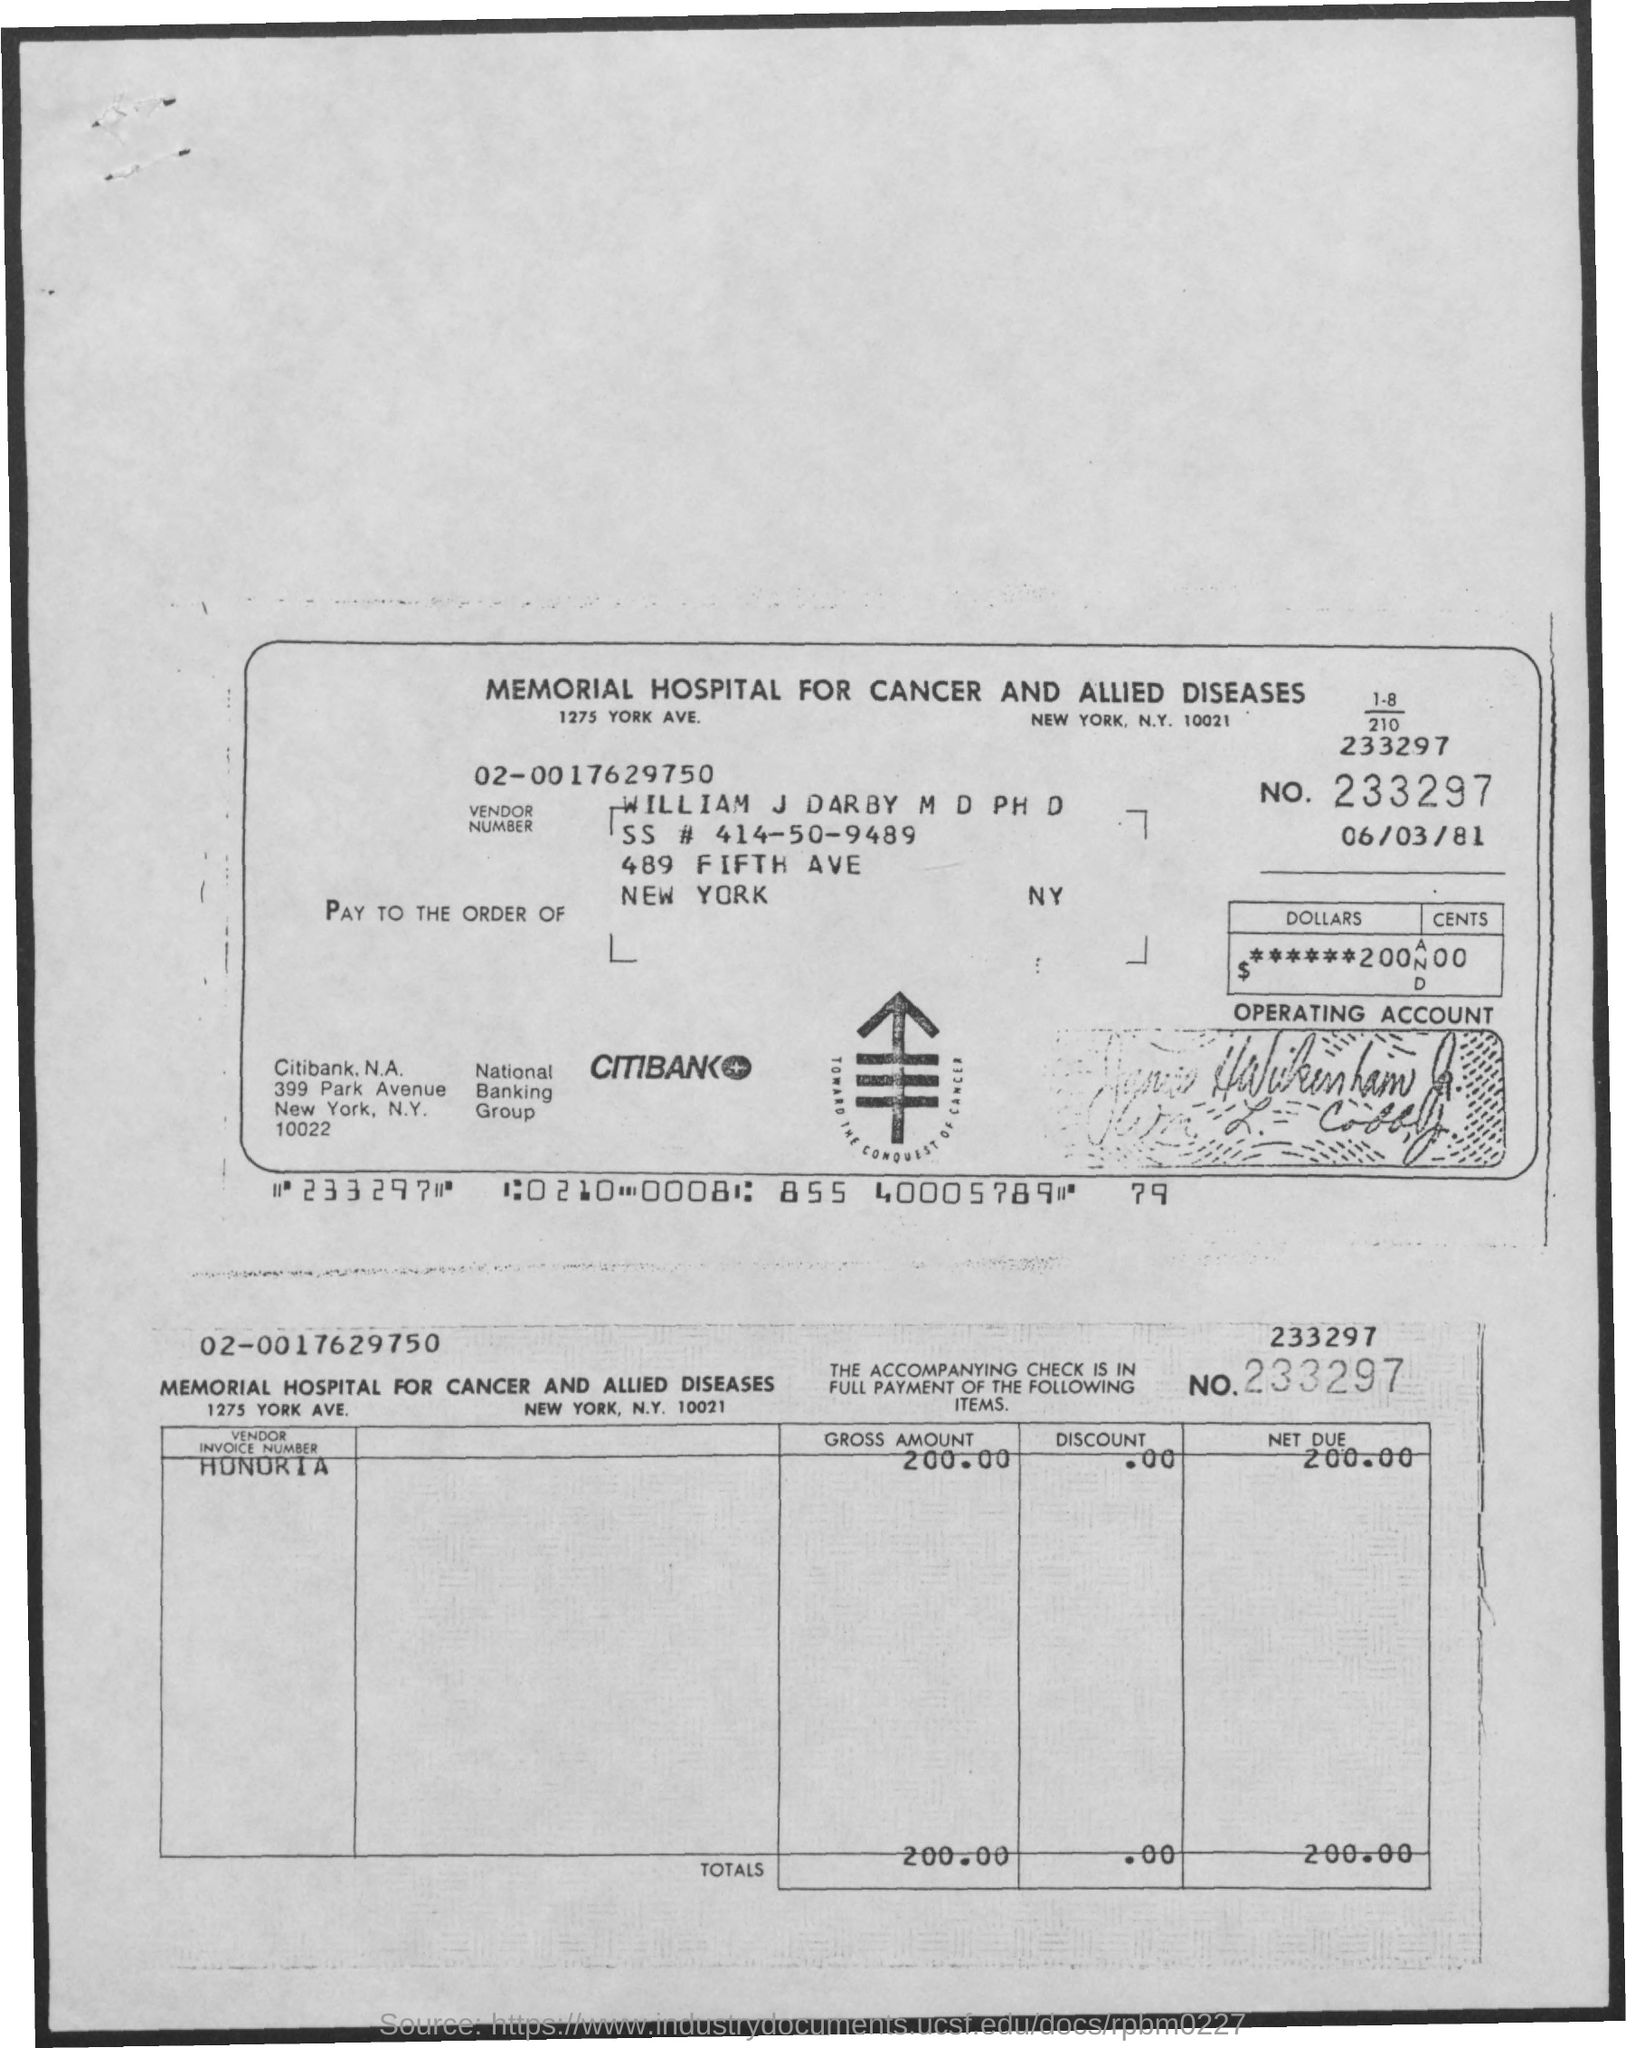What is the date mentioned ?
Ensure brevity in your answer.  06/03/81. What is mentioned in no. ?
Offer a very short reply. 233297. What is the name of the person ?
Give a very brief answer. William J. Darby. What is the name of the hospital ?
Provide a succinct answer. Memorial hospital for cancer and allied diseases. What is the gross amount ?
Provide a succinct answer. 200.00. How much is the net due amount ?
Make the answer very short. 200.00. What is the vendor number ?
Give a very brief answer. 02-0017629750. What is the total amount ?
Make the answer very short. 200.00. In which city the hospital is located ?
Keep it short and to the point. NEW YORK. What is the name of the bank ?
Your response must be concise. CITIBANK. 